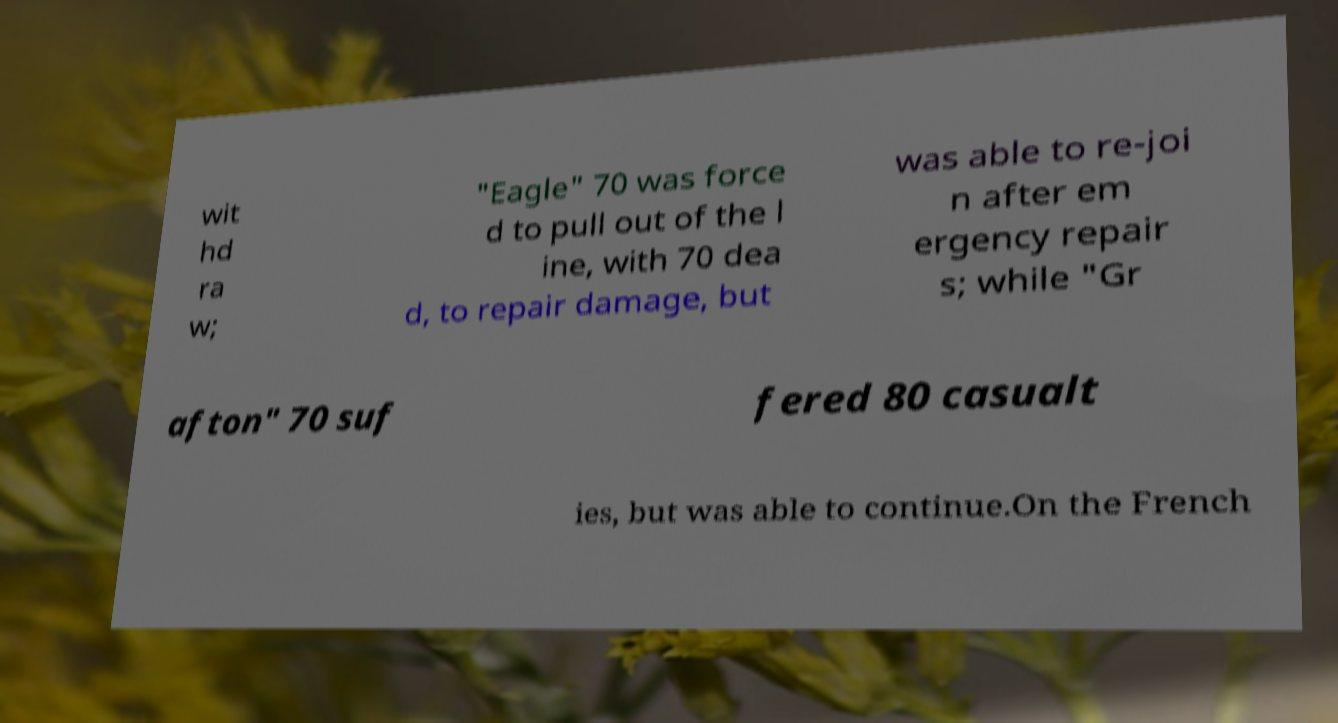Could you assist in decoding the text presented in this image and type it out clearly? wit hd ra w; "Eagle" 70 was force d to pull out of the l ine, with 70 dea d, to repair damage, but was able to re-joi n after em ergency repair s; while "Gr afton" 70 suf fered 80 casualt ies, but was able to continue.On the French 